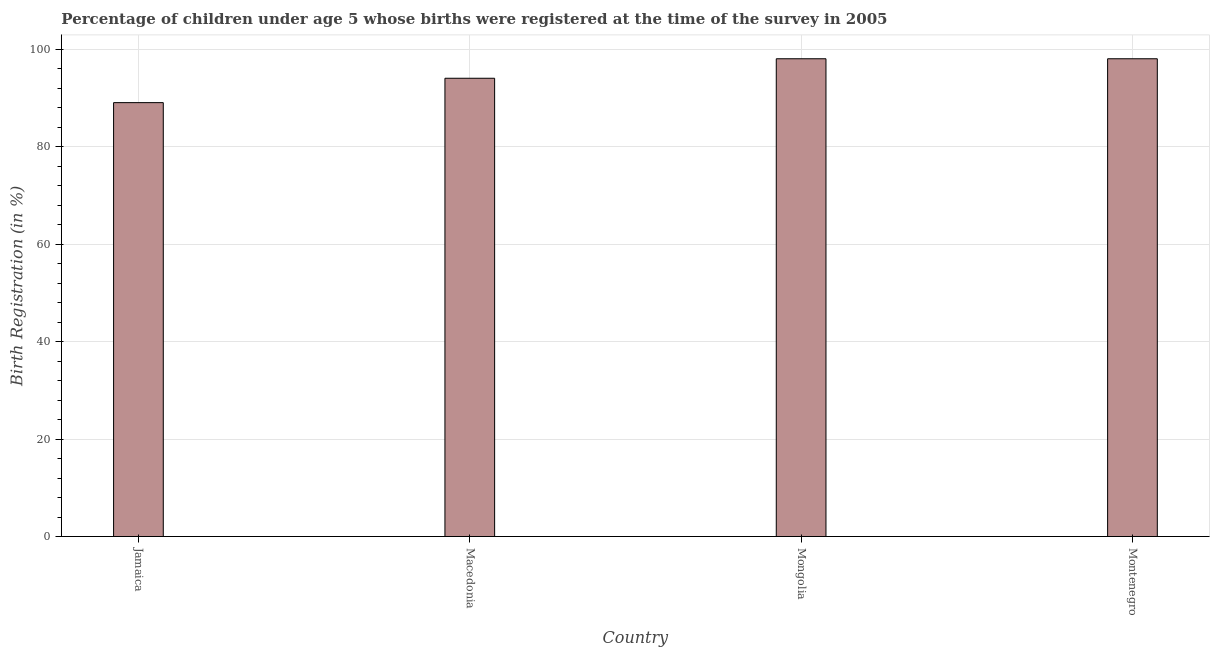Does the graph contain grids?
Give a very brief answer. Yes. What is the title of the graph?
Your answer should be compact. Percentage of children under age 5 whose births were registered at the time of the survey in 2005. What is the label or title of the X-axis?
Make the answer very short. Country. What is the label or title of the Y-axis?
Keep it short and to the point. Birth Registration (in %). What is the birth registration in Jamaica?
Your response must be concise. 89. Across all countries, what is the minimum birth registration?
Provide a succinct answer. 89. In which country was the birth registration maximum?
Offer a very short reply. Mongolia. In which country was the birth registration minimum?
Your answer should be very brief. Jamaica. What is the sum of the birth registration?
Provide a short and direct response. 379. What is the average birth registration per country?
Provide a succinct answer. 94.75. What is the median birth registration?
Make the answer very short. 96. What is the ratio of the birth registration in Jamaica to that in Macedonia?
Keep it short and to the point. 0.95. Is the birth registration in Mongolia less than that in Montenegro?
Give a very brief answer. No. Is the difference between the birth registration in Macedonia and Montenegro greater than the difference between any two countries?
Your response must be concise. No. In how many countries, is the birth registration greater than the average birth registration taken over all countries?
Offer a terse response. 2. How many bars are there?
Give a very brief answer. 4. What is the difference between two consecutive major ticks on the Y-axis?
Give a very brief answer. 20. What is the Birth Registration (in %) of Jamaica?
Offer a very short reply. 89. What is the Birth Registration (in %) of Macedonia?
Offer a terse response. 94. What is the Birth Registration (in %) of Montenegro?
Offer a very short reply. 98. What is the difference between the Birth Registration (in %) in Jamaica and Montenegro?
Keep it short and to the point. -9. What is the difference between the Birth Registration (in %) in Macedonia and Mongolia?
Offer a terse response. -4. What is the difference between the Birth Registration (in %) in Macedonia and Montenegro?
Ensure brevity in your answer.  -4. What is the difference between the Birth Registration (in %) in Mongolia and Montenegro?
Offer a very short reply. 0. What is the ratio of the Birth Registration (in %) in Jamaica to that in Macedonia?
Ensure brevity in your answer.  0.95. What is the ratio of the Birth Registration (in %) in Jamaica to that in Mongolia?
Your response must be concise. 0.91. What is the ratio of the Birth Registration (in %) in Jamaica to that in Montenegro?
Ensure brevity in your answer.  0.91. What is the ratio of the Birth Registration (in %) in Mongolia to that in Montenegro?
Your answer should be very brief. 1. 